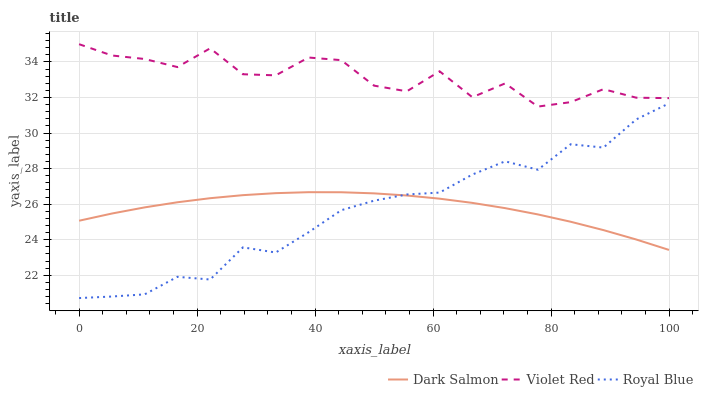Does Royal Blue have the minimum area under the curve?
Answer yes or no. Yes. Does Violet Red have the maximum area under the curve?
Answer yes or no. Yes. Does Dark Salmon have the minimum area under the curve?
Answer yes or no. No. Does Dark Salmon have the maximum area under the curve?
Answer yes or no. No. Is Dark Salmon the smoothest?
Answer yes or no. Yes. Is Violet Red the roughest?
Answer yes or no. Yes. Is Violet Red the smoothest?
Answer yes or no. No. Is Dark Salmon the roughest?
Answer yes or no. No. Does Royal Blue have the lowest value?
Answer yes or no. Yes. Does Dark Salmon have the lowest value?
Answer yes or no. No. Does Violet Red have the highest value?
Answer yes or no. Yes. Does Dark Salmon have the highest value?
Answer yes or no. No. Is Dark Salmon less than Violet Red?
Answer yes or no. Yes. Is Violet Red greater than Royal Blue?
Answer yes or no. Yes. Does Royal Blue intersect Dark Salmon?
Answer yes or no. Yes. Is Royal Blue less than Dark Salmon?
Answer yes or no. No. Is Royal Blue greater than Dark Salmon?
Answer yes or no. No. Does Dark Salmon intersect Violet Red?
Answer yes or no. No. 